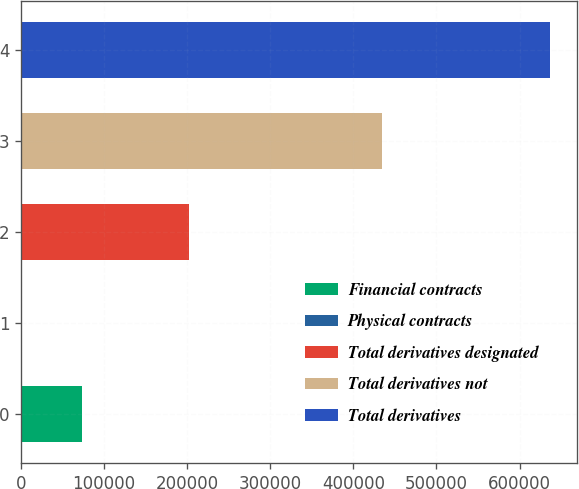Convert chart. <chart><loc_0><loc_0><loc_500><loc_500><bar_chart><fcel>Financial contracts<fcel>Physical contracts<fcel>Total derivatives designated<fcel>Total derivatives not<fcel>Total derivatives<nl><fcel>73346<fcel>344<fcel>202356<fcel>434885<fcel>637241<nl></chart> 